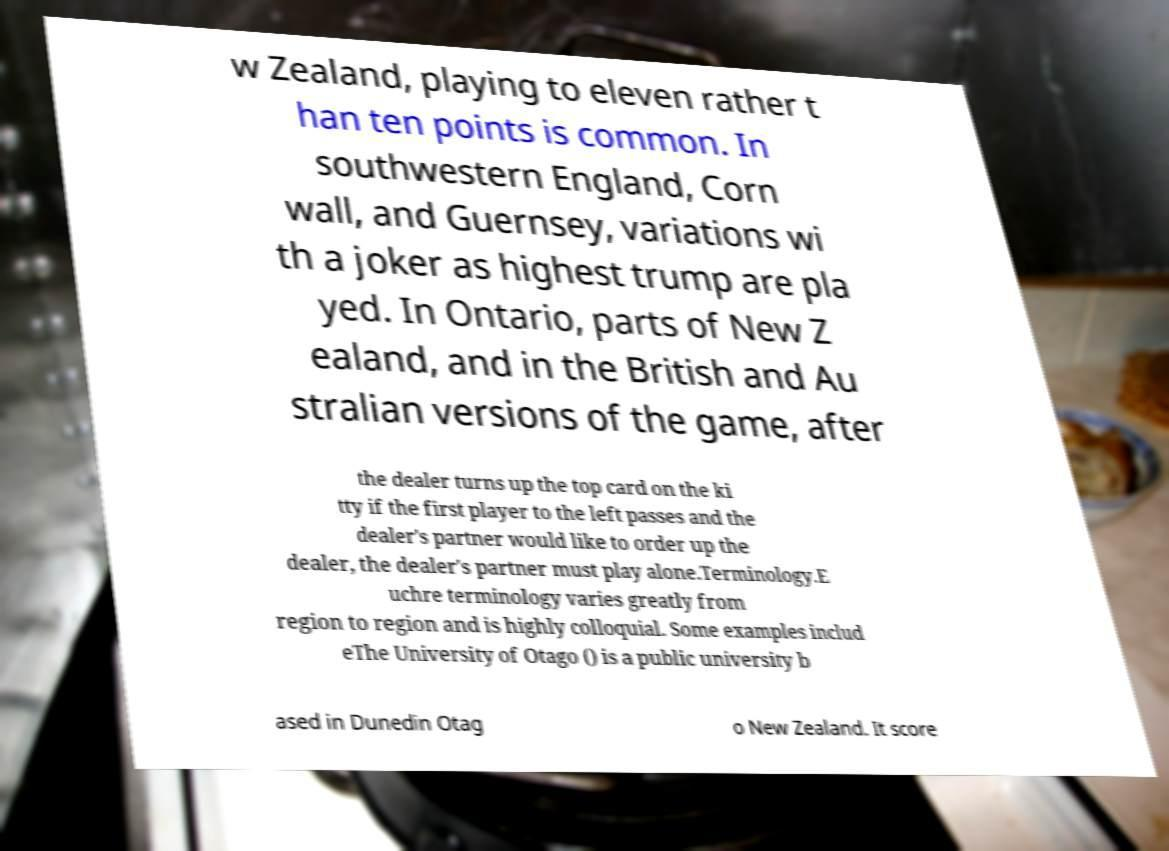For documentation purposes, I need the text within this image transcribed. Could you provide that? w Zealand, playing to eleven rather t han ten points is common. In southwestern England, Corn wall, and Guernsey, variations wi th a joker as highest trump are pla yed. In Ontario, parts of New Z ealand, and in the British and Au stralian versions of the game, after the dealer turns up the top card on the ki tty if the first player to the left passes and the dealer's partner would like to order up the dealer, the dealer's partner must play alone.Terminology.E uchre terminology varies greatly from region to region and is highly colloquial. Some examples includ eThe University of Otago () is a public university b ased in Dunedin Otag o New Zealand. It score 